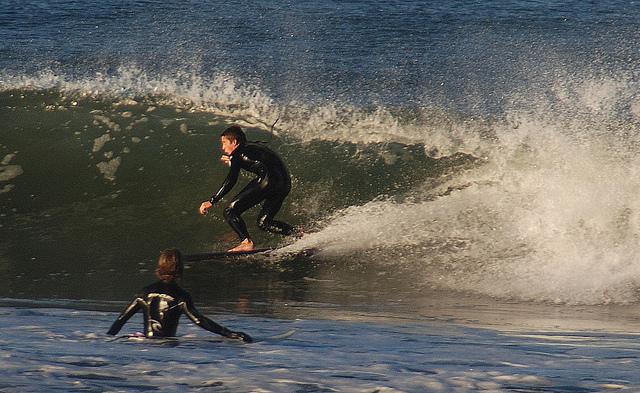Is the water cold?
Answer briefly. Yes. How big is the wave?
Write a very short answer. Medium. Is he an experienced surfer?
Quick response, please. Yes. 